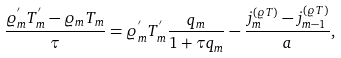<formula> <loc_0><loc_0><loc_500><loc_500>\frac { \varrho _ { m } ^ { ^ { \prime } } T _ { m } ^ { ^ { \prime } } - \varrho _ { m } T _ { m } } { \tau } = \varrho _ { m } ^ { ^ { \prime } } T _ { m } ^ { ^ { \prime } } \frac { q _ { m } } { 1 + \tau q _ { m } } - \frac { j _ { m } ^ { ( \varrho T ) } - j _ { m - 1 } ^ { ( \varrho T ) } } { a } ,</formula> 